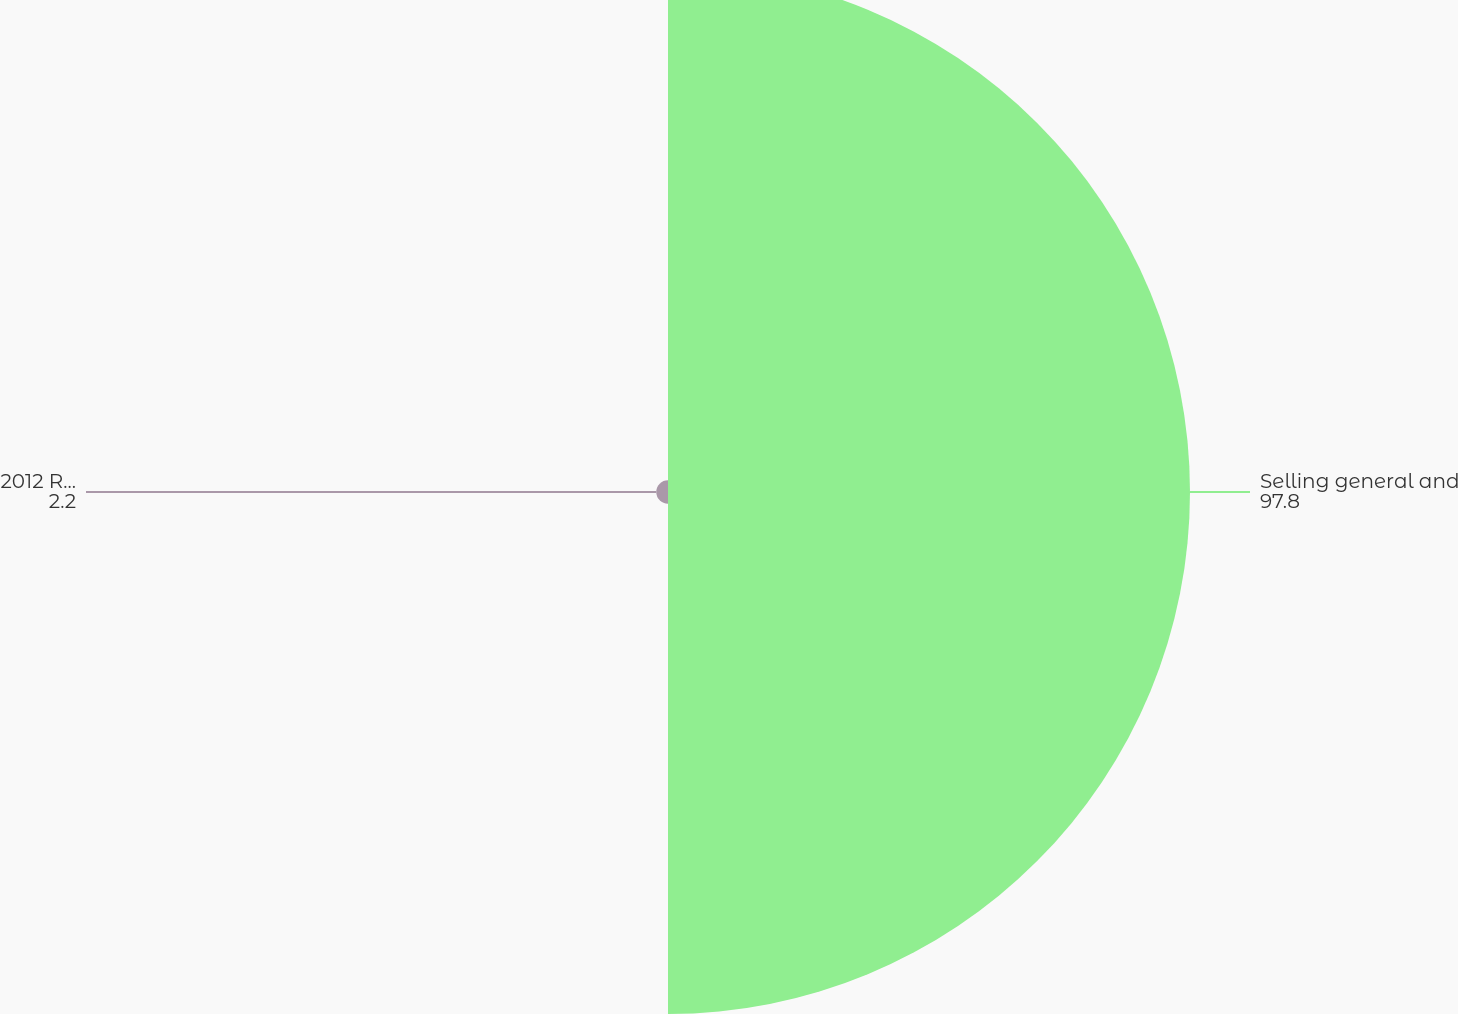Convert chart to OTSL. <chart><loc_0><loc_0><loc_500><loc_500><pie_chart><fcel>Selling general and<fcel>2012 Restructuring Program<nl><fcel>97.8%<fcel>2.2%<nl></chart> 